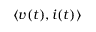<formula> <loc_0><loc_0><loc_500><loc_500>\langle v ( t ) , i ( t ) \rangle</formula> 